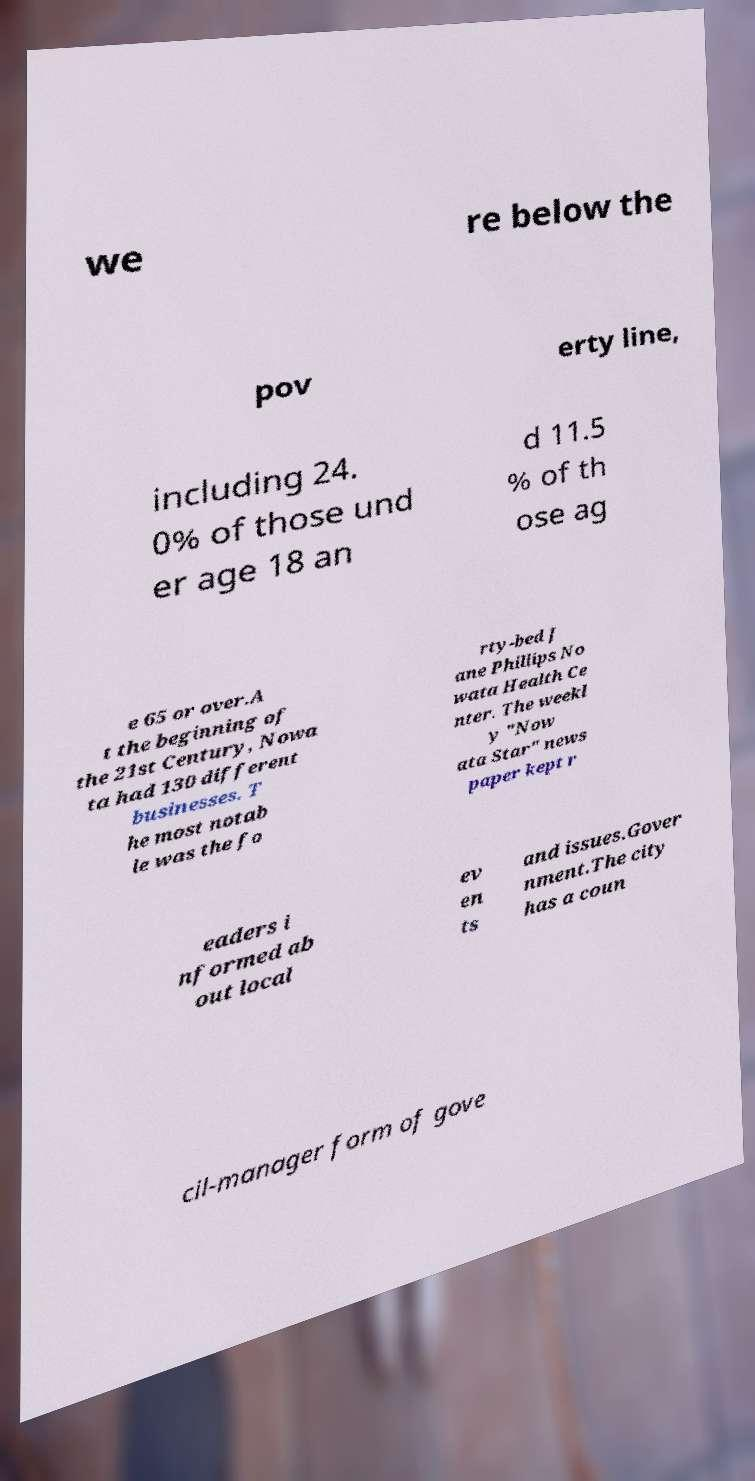Please identify and transcribe the text found in this image. we re below the pov erty line, including 24. 0% of those und er age 18 an d 11.5 % of th ose ag e 65 or over.A t the beginning of the 21st Century, Nowa ta had 130 different businesses. T he most notab le was the fo rty-bed J ane Phillips No wata Health Ce nter. The weekl y "Now ata Star" news paper kept r eaders i nformed ab out local ev en ts and issues.Gover nment.The city has a coun cil-manager form of gove 